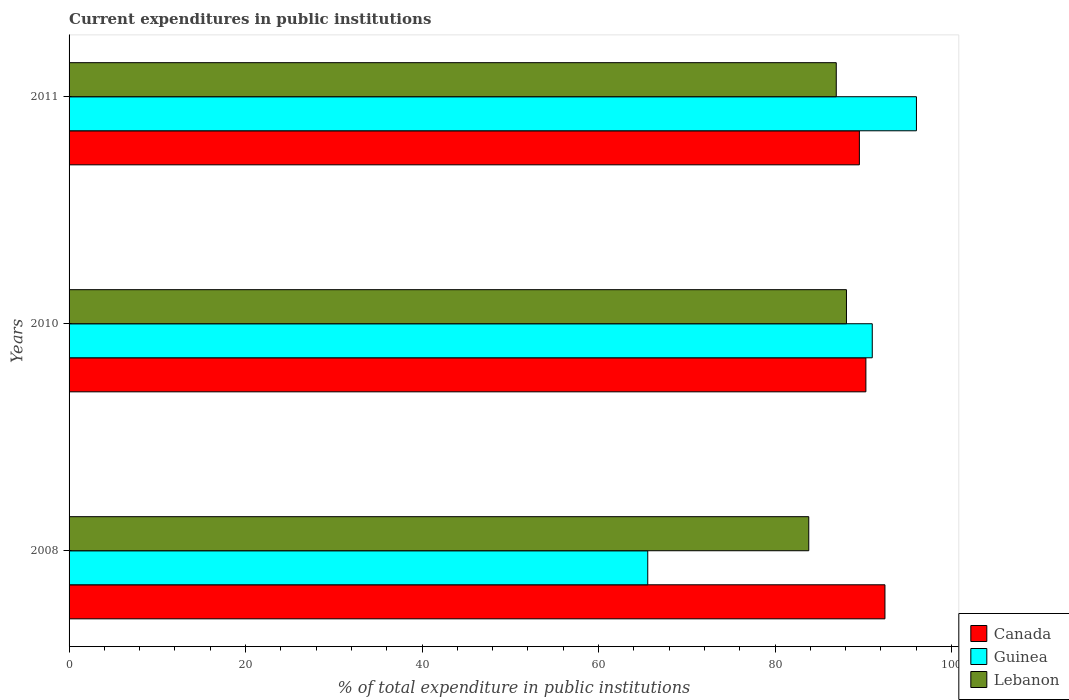How many groups of bars are there?
Provide a short and direct response. 3. Are the number of bars per tick equal to the number of legend labels?
Your answer should be compact. Yes. Are the number of bars on each tick of the Y-axis equal?
Ensure brevity in your answer.  Yes. What is the label of the 2nd group of bars from the top?
Your response must be concise. 2010. What is the current expenditures in public institutions in Guinea in 2010?
Give a very brief answer. 91.01. Across all years, what is the maximum current expenditures in public institutions in Lebanon?
Give a very brief answer. 88.09. Across all years, what is the minimum current expenditures in public institutions in Lebanon?
Give a very brief answer. 83.82. In which year was the current expenditures in public institutions in Canada maximum?
Your answer should be very brief. 2008. In which year was the current expenditures in public institutions in Canada minimum?
Make the answer very short. 2011. What is the total current expenditures in public institutions in Canada in the graph?
Your answer should be compact. 272.29. What is the difference between the current expenditures in public institutions in Canada in 2008 and that in 2011?
Offer a very short reply. 2.9. What is the difference between the current expenditures in public institutions in Guinea in 2010 and the current expenditures in public institutions in Lebanon in 2011?
Offer a very short reply. 4.08. What is the average current expenditures in public institutions in Lebanon per year?
Your response must be concise. 86.28. In the year 2011, what is the difference between the current expenditures in public institutions in Canada and current expenditures in public institutions in Guinea?
Keep it short and to the point. -6.47. In how many years, is the current expenditures in public institutions in Canada greater than 84 %?
Give a very brief answer. 3. What is the ratio of the current expenditures in public institutions in Canada in 2008 to that in 2010?
Offer a very short reply. 1.02. Is the current expenditures in public institutions in Canada in 2008 less than that in 2010?
Ensure brevity in your answer.  No. What is the difference between the highest and the second highest current expenditures in public institutions in Canada?
Offer a very short reply. 2.16. What is the difference between the highest and the lowest current expenditures in public institutions in Canada?
Your response must be concise. 2.9. In how many years, is the current expenditures in public institutions in Lebanon greater than the average current expenditures in public institutions in Lebanon taken over all years?
Your answer should be compact. 2. Is the sum of the current expenditures in public institutions in Guinea in 2008 and 2010 greater than the maximum current expenditures in public institutions in Canada across all years?
Your answer should be compact. Yes. What does the 3rd bar from the top in 2010 represents?
Keep it short and to the point. Canada. What does the 3rd bar from the bottom in 2010 represents?
Provide a short and direct response. Lebanon. Is it the case that in every year, the sum of the current expenditures in public institutions in Guinea and current expenditures in public institutions in Lebanon is greater than the current expenditures in public institutions in Canada?
Ensure brevity in your answer.  Yes. Are all the bars in the graph horizontal?
Offer a terse response. Yes. How many years are there in the graph?
Ensure brevity in your answer.  3. Are the values on the major ticks of X-axis written in scientific E-notation?
Give a very brief answer. No. Does the graph contain any zero values?
Make the answer very short. No. Does the graph contain grids?
Provide a succinct answer. No. How are the legend labels stacked?
Keep it short and to the point. Vertical. What is the title of the graph?
Provide a short and direct response. Current expenditures in public institutions. Does "Maldives" appear as one of the legend labels in the graph?
Offer a terse response. No. What is the label or title of the X-axis?
Provide a short and direct response. % of total expenditure in public institutions. What is the label or title of the Y-axis?
Your answer should be compact. Years. What is the % of total expenditure in public institutions of Canada in 2008?
Keep it short and to the point. 92.45. What is the % of total expenditure in public institutions in Guinea in 2008?
Provide a short and direct response. 65.57. What is the % of total expenditure in public institutions in Lebanon in 2008?
Your response must be concise. 83.82. What is the % of total expenditure in public institutions of Canada in 2010?
Your answer should be compact. 90.29. What is the % of total expenditure in public institutions in Guinea in 2010?
Keep it short and to the point. 91.01. What is the % of total expenditure in public institutions in Lebanon in 2010?
Offer a very short reply. 88.09. What is the % of total expenditure in public institutions of Canada in 2011?
Ensure brevity in your answer.  89.55. What is the % of total expenditure in public institutions in Guinea in 2011?
Make the answer very short. 96.02. What is the % of total expenditure in public institutions of Lebanon in 2011?
Your response must be concise. 86.93. Across all years, what is the maximum % of total expenditure in public institutions of Canada?
Provide a succinct answer. 92.45. Across all years, what is the maximum % of total expenditure in public institutions of Guinea?
Your answer should be compact. 96.02. Across all years, what is the maximum % of total expenditure in public institutions in Lebanon?
Provide a succinct answer. 88.09. Across all years, what is the minimum % of total expenditure in public institutions of Canada?
Make the answer very short. 89.55. Across all years, what is the minimum % of total expenditure in public institutions in Guinea?
Offer a very short reply. 65.57. Across all years, what is the minimum % of total expenditure in public institutions of Lebanon?
Keep it short and to the point. 83.82. What is the total % of total expenditure in public institutions in Canada in the graph?
Offer a very short reply. 272.29. What is the total % of total expenditure in public institutions of Guinea in the graph?
Provide a succinct answer. 252.6. What is the total % of total expenditure in public institutions in Lebanon in the graph?
Ensure brevity in your answer.  258.84. What is the difference between the % of total expenditure in public institutions of Canada in 2008 and that in 2010?
Offer a very short reply. 2.16. What is the difference between the % of total expenditure in public institutions in Guinea in 2008 and that in 2010?
Give a very brief answer. -25.44. What is the difference between the % of total expenditure in public institutions of Lebanon in 2008 and that in 2010?
Ensure brevity in your answer.  -4.27. What is the difference between the % of total expenditure in public institutions in Canada in 2008 and that in 2011?
Provide a short and direct response. 2.9. What is the difference between the % of total expenditure in public institutions of Guinea in 2008 and that in 2011?
Provide a short and direct response. -30.45. What is the difference between the % of total expenditure in public institutions of Lebanon in 2008 and that in 2011?
Your answer should be compact. -3.12. What is the difference between the % of total expenditure in public institutions in Canada in 2010 and that in 2011?
Offer a very short reply. 0.74. What is the difference between the % of total expenditure in public institutions in Guinea in 2010 and that in 2011?
Provide a succinct answer. -5.01. What is the difference between the % of total expenditure in public institutions in Lebanon in 2010 and that in 2011?
Make the answer very short. 1.16. What is the difference between the % of total expenditure in public institutions in Canada in 2008 and the % of total expenditure in public institutions in Guinea in 2010?
Give a very brief answer. 1.44. What is the difference between the % of total expenditure in public institutions of Canada in 2008 and the % of total expenditure in public institutions of Lebanon in 2010?
Provide a short and direct response. 4.36. What is the difference between the % of total expenditure in public institutions of Guinea in 2008 and the % of total expenditure in public institutions of Lebanon in 2010?
Offer a very short reply. -22.52. What is the difference between the % of total expenditure in public institutions in Canada in 2008 and the % of total expenditure in public institutions in Guinea in 2011?
Offer a terse response. -3.57. What is the difference between the % of total expenditure in public institutions of Canada in 2008 and the % of total expenditure in public institutions of Lebanon in 2011?
Ensure brevity in your answer.  5.52. What is the difference between the % of total expenditure in public institutions of Guinea in 2008 and the % of total expenditure in public institutions of Lebanon in 2011?
Make the answer very short. -21.36. What is the difference between the % of total expenditure in public institutions of Canada in 2010 and the % of total expenditure in public institutions of Guinea in 2011?
Your answer should be compact. -5.73. What is the difference between the % of total expenditure in public institutions of Canada in 2010 and the % of total expenditure in public institutions of Lebanon in 2011?
Provide a short and direct response. 3.36. What is the difference between the % of total expenditure in public institutions in Guinea in 2010 and the % of total expenditure in public institutions in Lebanon in 2011?
Offer a terse response. 4.08. What is the average % of total expenditure in public institutions of Canada per year?
Your answer should be very brief. 90.76. What is the average % of total expenditure in public institutions in Guinea per year?
Ensure brevity in your answer.  84.2. What is the average % of total expenditure in public institutions in Lebanon per year?
Your answer should be very brief. 86.28. In the year 2008, what is the difference between the % of total expenditure in public institutions in Canada and % of total expenditure in public institutions in Guinea?
Provide a short and direct response. 26.88. In the year 2008, what is the difference between the % of total expenditure in public institutions in Canada and % of total expenditure in public institutions in Lebanon?
Make the answer very short. 8.63. In the year 2008, what is the difference between the % of total expenditure in public institutions in Guinea and % of total expenditure in public institutions in Lebanon?
Your response must be concise. -18.25. In the year 2010, what is the difference between the % of total expenditure in public institutions of Canada and % of total expenditure in public institutions of Guinea?
Your answer should be compact. -0.72. In the year 2010, what is the difference between the % of total expenditure in public institutions of Canada and % of total expenditure in public institutions of Lebanon?
Your answer should be very brief. 2.2. In the year 2010, what is the difference between the % of total expenditure in public institutions of Guinea and % of total expenditure in public institutions of Lebanon?
Ensure brevity in your answer.  2.92. In the year 2011, what is the difference between the % of total expenditure in public institutions of Canada and % of total expenditure in public institutions of Guinea?
Provide a succinct answer. -6.47. In the year 2011, what is the difference between the % of total expenditure in public institutions of Canada and % of total expenditure in public institutions of Lebanon?
Make the answer very short. 2.62. In the year 2011, what is the difference between the % of total expenditure in public institutions of Guinea and % of total expenditure in public institutions of Lebanon?
Provide a succinct answer. 9.08. What is the ratio of the % of total expenditure in public institutions in Canada in 2008 to that in 2010?
Offer a very short reply. 1.02. What is the ratio of the % of total expenditure in public institutions in Guinea in 2008 to that in 2010?
Provide a succinct answer. 0.72. What is the ratio of the % of total expenditure in public institutions of Lebanon in 2008 to that in 2010?
Keep it short and to the point. 0.95. What is the ratio of the % of total expenditure in public institutions in Canada in 2008 to that in 2011?
Ensure brevity in your answer.  1.03. What is the ratio of the % of total expenditure in public institutions of Guinea in 2008 to that in 2011?
Provide a succinct answer. 0.68. What is the ratio of the % of total expenditure in public institutions in Lebanon in 2008 to that in 2011?
Your answer should be compact. 0.96. What is the ratio of the % of total expenditure in public institutions in Canada in 2010 to that in 2011?
Provide a succinct answer. 1.01. What is the ratio of the % of total expenditure in public institutions of Guinea in 2010 to that in 2011?
Keep it short and to the point. 0.95. What is the ratio of the % of total expenditure in public institutions in Lebanon in 2010 to that in 2011?
Give a very brief answer. 1.01. What is the difference between the highest and the second highest % of total expenditure in public institutions in Canada?
Make the answer very short. 2.16. What is the difference between the highest and the second highest % of total expenditure in public institutions of Guinea?
Provide a short and direct response. 5.01. What is the difference between the highest and the second highest % of total expenditure in public institutions of Lebanon?
Provide a short and direct response. 1.16. What is the difference between the highest and the lowest % of total expenditure in public institutions of Canada?
Offer a terse response. 2.9. What is the difference between the highest and the lowest % of total expenditure in public institutions of Guinea?
Provide a succinct answer. 30.45. What is the difference between the highest and the lowest % of total expenditure in public institutions of Lebanon?
Your response must be concise. 4.27. 